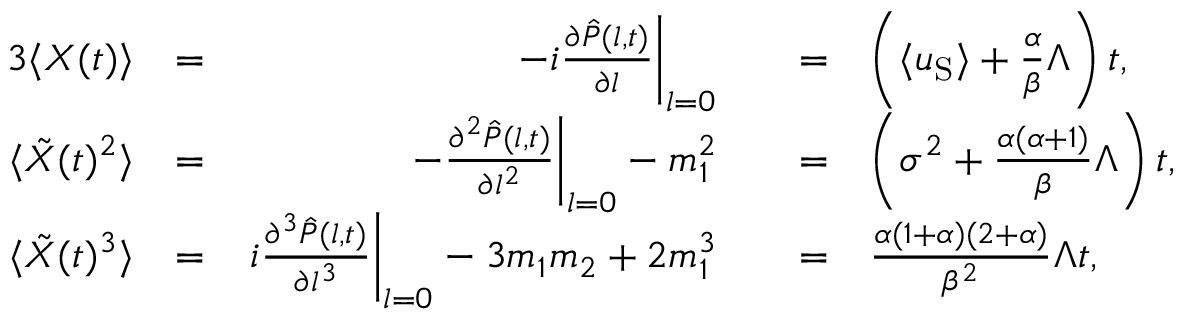<formula> <loc_0><loc_0><loc_500><loc_500>\begin{array} { r l r l r l } { { 3 } \langle X ( t ) \rangle } & { = } & { - i \frac { \partial \hat { P } ( l , t ) } { \partial l } \right | _ { l = 0 } } & { = } & { \left ( \langle u _ { S } \rangle + \frac { \alpha } { \beta } \Lambda \right ) t , } \\ { \langle \tilde { X } ( t ) ^ { 2 } \rangle } & { = } & { - \frac { \partial ^ { 2 } \hat { P } ( l , t ) } { \partial l ^ { 2 } } \right | _ { l = 0 } - m _ { 1 } ^ { 2 } } & { = } & { \left ( \sigma ^ { 2 } + \frac { \alpha ( \alpha + 1 ) } { \beta } \Lambda \right ) t , } \\ { \langle \tilde { X } ( t ) ^ { 3 } \rangle } & { = } & { i \frac { \partial ^ { 3 } \hat { P } ( l , t ) } { \partial l ^ { 3 } } \right | _ { l = 0 } - 3 m _ { 1 } m _ { 2 } + 2 m _ { 1 } ^ { 3 } } & { = } & { \frac { \alpha ( 1 + \alpha ) ( 2 + \alpha ) } { \beta ^ { 2 } } \Lambda t , } \end{array}</formula> 